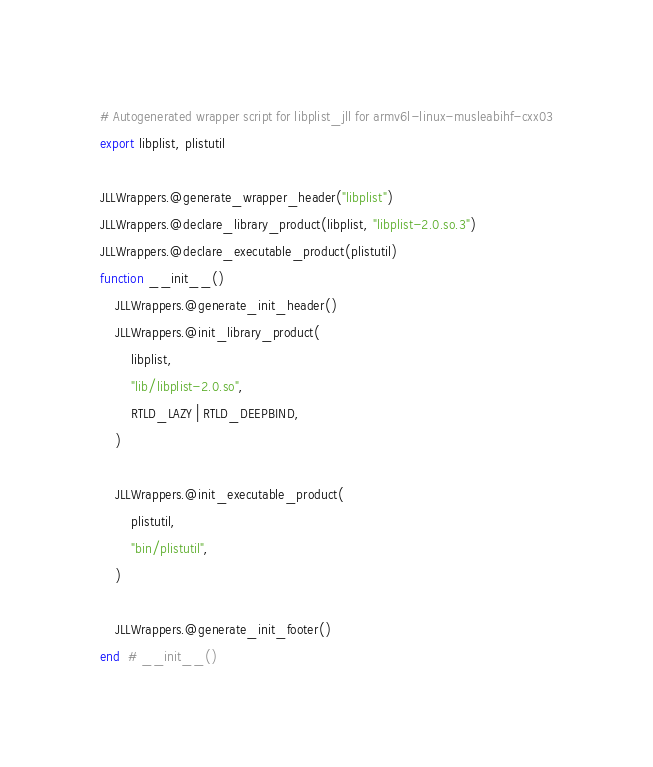<code> <loc_0><loc_0><loc_500><loc_500><_Julia_># Autogenerated wrapper script for libplist_jll for armv6l-linux-musleabihf-cxx03
export libplist, plistutil

JLLWrappers.@generate_wrapper_header("libplist")
JLLWrappers.@declare_library_product(libplist, "libplist-2.0.so.3")
JLLWrappers.@declare_executable_product(plistutil)
function __init__()
    JLLWrappers.@generate_init_header()
    JLLWrappers.@init_library_product(
        libplist,
        "lib/libplist-2.0.so",
        RTLD_LAZY | RTLD_DEEPBIND,
    )

    JLLWrappers.@init_executable_product(
        plistutil,
        "bin/plistutil",
    )

    JLLWrappers.@generate_init_footer()
end  # __init__()
</code> 